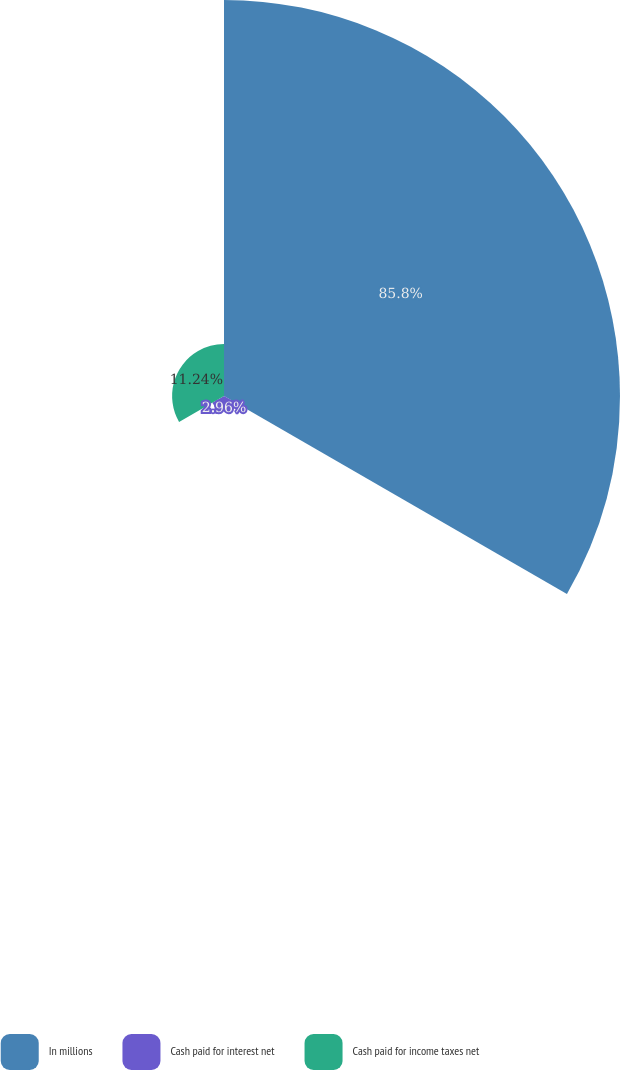Convert chart to OTSL. <chart><loc_0><loc_0><loc_500><loc_500><pie_chart><fcel>In millions<fcel>Cash paid for interest net<fcel>Cash paid for income taxes net<nl><fcel>85.8%<fcel>2.96%<fcel>11.24%<nl></chart> 